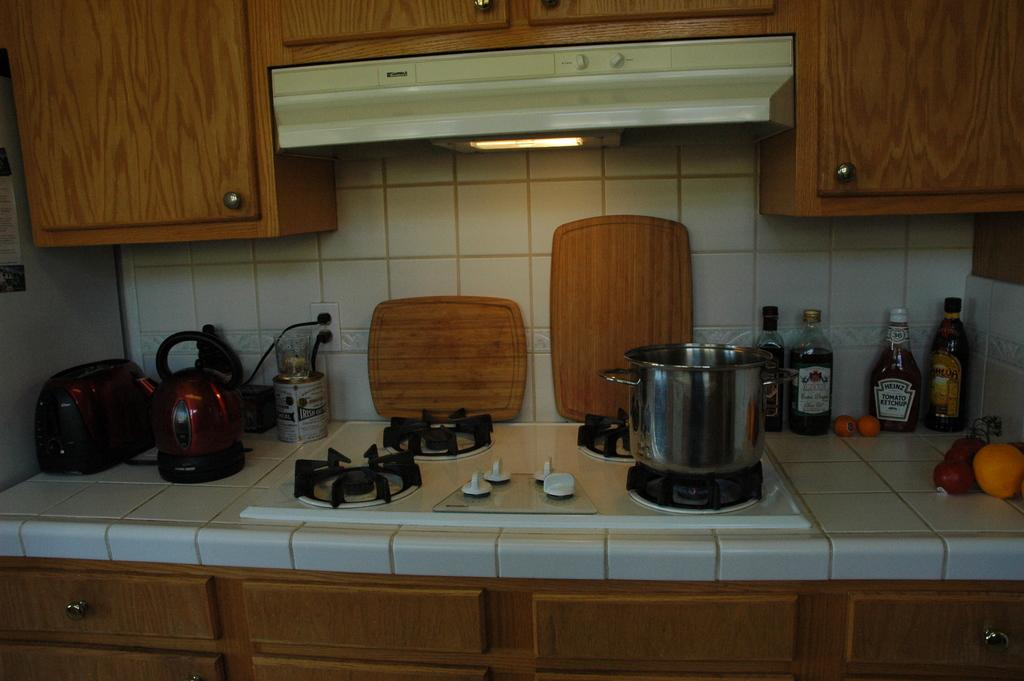<image>
Offer a succinct explanation of the picture presented. Some pots and pans sit on a kitchen counter, along with some bottles that includes a bottle of Heinz ketchup. 